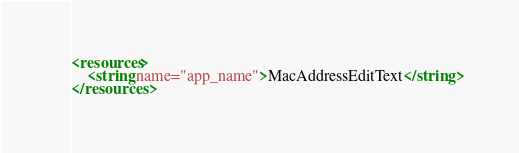<code> <loc_0><loc_0><loc_500><loc_500><_XML_><resources>
    <string name="app_name">MacAddressEditText</string>
</resources>
</code> 